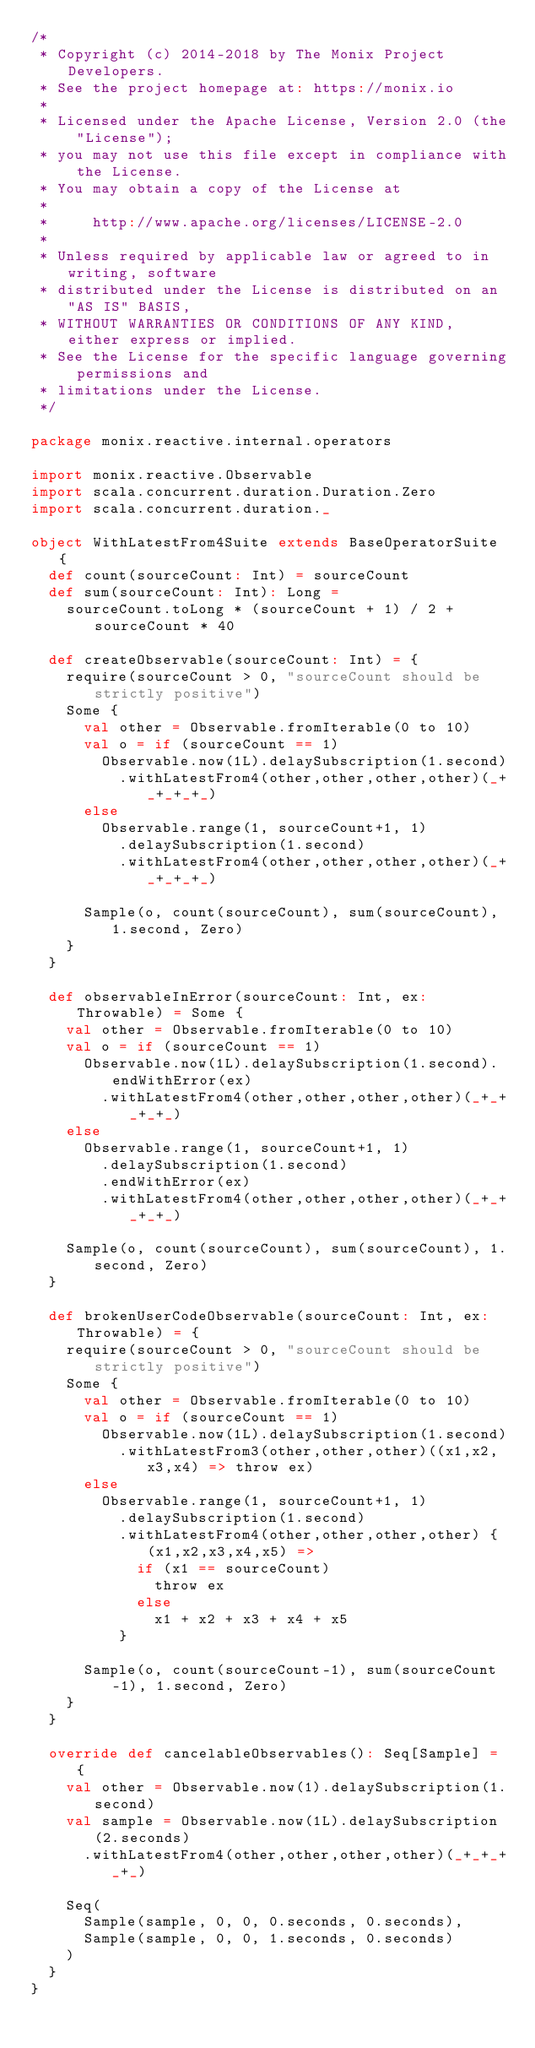<code> <loc_0><loc_0><loc_500><loc_500><_Scala_>/*
 * Copyright (c) 2014-2018 by The Monix Project Developers.
 * See the project homepage at: https://monix.io
 *
 * Licensed under the Apache License, Version 2.0 (the "License");
 * you may not use this file except in compliance with the License.
 * You may obtain a copy of the License at
 *
 *     http://www.apache.org/licenses/LICENSE-2.0
 *
 * Unless required by applicable law or agreed to in writing, software
 * distributed under the License is distributed on an "AS IS" BASIS,
 * WITHOUT WARRANTIES OR CONDITIONS OF ANY KIND, either express or implied.
 * See the License for the specific language governing permissions and
 * limitations under the License.
 */

package monix.reactive.internal.operators

import monix.reactive.Observable
import scala.concurrent.duration.Duration.Zero
import scala.concurrent.duration._

object WithLatestFrom4Suite extends BaseOperatorSuite {
  def count(sourceCount: Int) = sourceCount
  def sum(sourceCount: Int): Long =
    sourceCount.toLong * (sourceCount + 1) / 2 + sourceCount * 40

  def createObservable(sourceCount: Int) = {
    require(sourceCount > 0, "sourceCount should be strictly positive")
    Some {
      val other = Observable.fromIterable(0 to 10)
      val o = if (sourceCount == 1)
        Observable.now(1L).delaySubscription(1.second)
          .withLatestFrom4(other,other,other,other)(_+_+_+_+_)
      else
        Observable.range(1, sourceCount+1, 1)
          .delaySubscription(1.second)
          .withLatestFrom4(other,other,other,other)(_+_+_+_+_)

      Sample(o, count(sourceCount), sum(sourceCount), 1.second, Zero)
    }
  }

  def observableInError(sourceCount: Int, ex: Throwable) = Some {
    val other = Observable.fromIterable(0 to 10)
    val o = if (sourceCount == 1)
      Observable.now(1L).delaySubscription(1.second).endWithError(ex)
        .withLatestFrom4(other,other,other,other)(_+_+_+_+_)
    else
      Observable.range(1, sourceCount+1, 1)
        .delaySubscription(1.second)
        .endWithError(ex)
        .withLatestFrom4(other,other,other,other)(_+_+_+_+_)

    Sample(o, count(sourceCount), sum(sourceCount), 1.second, Zero)
  }

  def brokenUserCodeObservable(sourceCount: Int, ex: Throwable) = {
    require(sourceCount > 0, "sourceCount should be strictly positive")
    Some {
      val other = Observable.fromIterable(0 to 10)
      val o = if (sourceCount == 1)
        Observable.now(1L).delaySubscription(1.second)
          .withLatestFrom3(other,other,other)((x1,x2,x3,x4) => throw ex)
      else
        Observable.range(1, sourceCount+1, 1)
          .delaySubscription(1.second)
          .withLatestFrom4(other,other,other,other) { (x1,x2,x3,x4,x5) =>
            if (x1 == sourceCount)
              throw ex
            else
              x1 + x2 + x3 + x4 + x5
          }

      Sample(o, count(sourceCount-1), sum(sourceCount-1), 1.second, Zero)
    }
  }

  override def cancelableObservables(): Seq[Sample] = {
    val other = Observable.now(1).delaySubscription(1.second)
    val sample = Observable.now(1L).delaySubscription(2.seconds)
      .withLatestFrom4(other,other,other,other)(_+_+_+_+_)

    Seq(
      Sample(sample, 0, 0, 0.seconds, 0.seconds),
      Sample(sample, 0, 0, 1.seconds, 0.seconds)
    )
  }
}</code> 